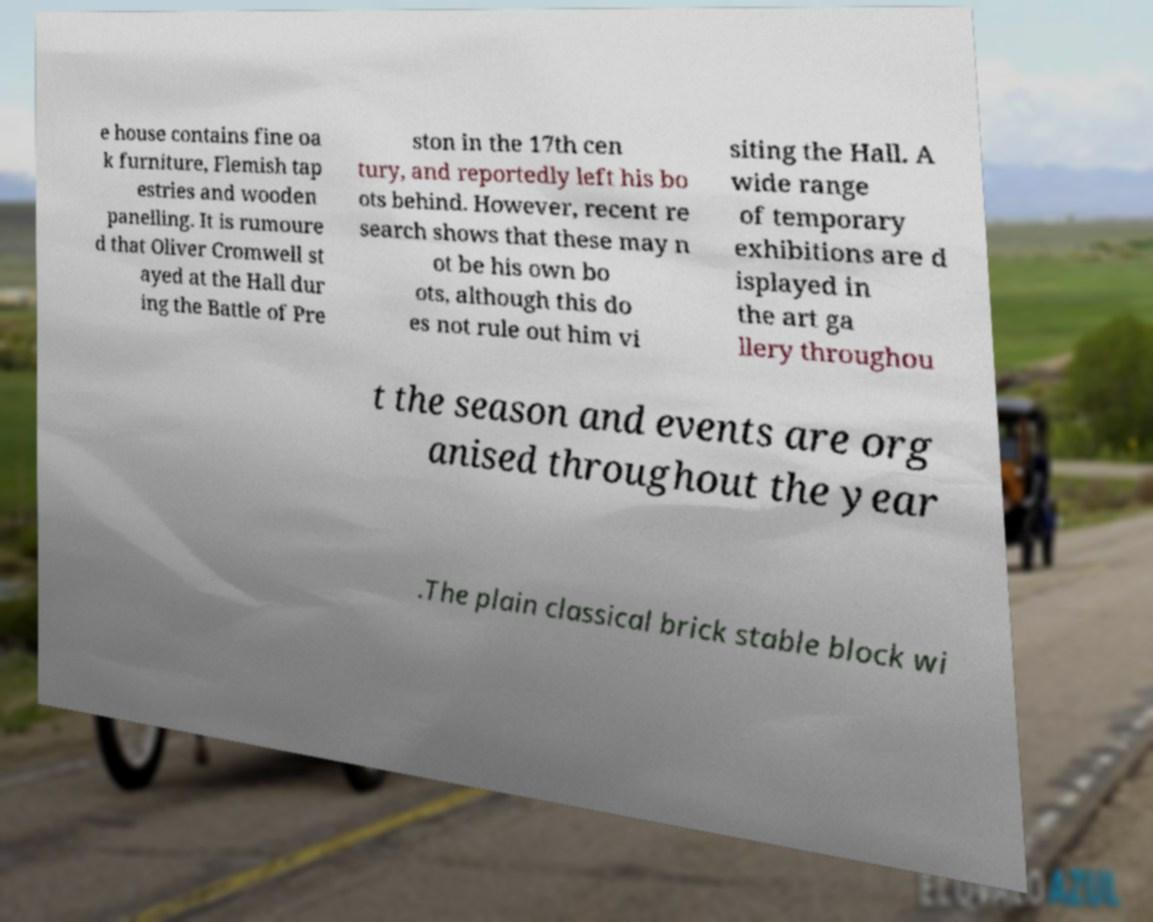Can you accurately transcribe the text from the provided image for me? e house contains fine oa k furniture, Flemish tap estries and wooden panelling. It is rumoure d that Oliver Cromwell st ayed at the Hall dur ing the Battle of Pre ston in the 17th cen tury, and reportedly left his bo ots behind. However, recent re search shows that these may n ot be his own bo ots, although this do es not rule out him vi siting the Hall. A wide range of temporary exhibitions are d isplayed in the art ga llery throughou t the season and events are org anised throughout the year .The plain classical brick stable block wi 